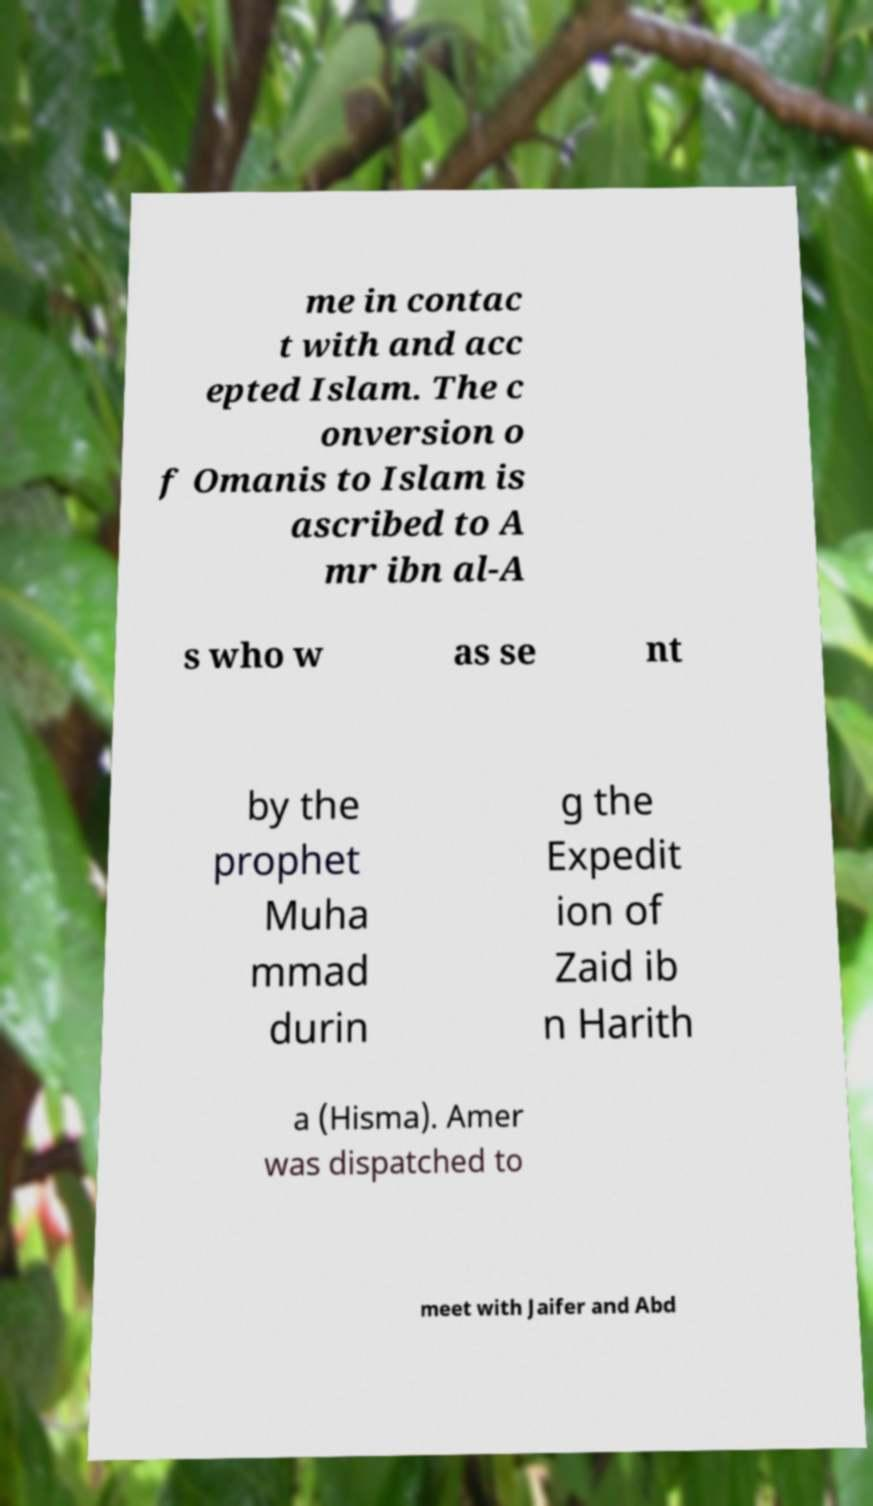What messages or text are displayed in this image? I need them in a readable, typed format. me in contac t with and acc epted Islam. The c onversion o f Omanis to Islam is ascribed to A mr ibn al-A s who w as se nt by the prophet Muha mmad durin g the Expedit ion of Zaid ib n Harith a (Hisma). Amer was dispatched to meet with Jaifer and Abd 